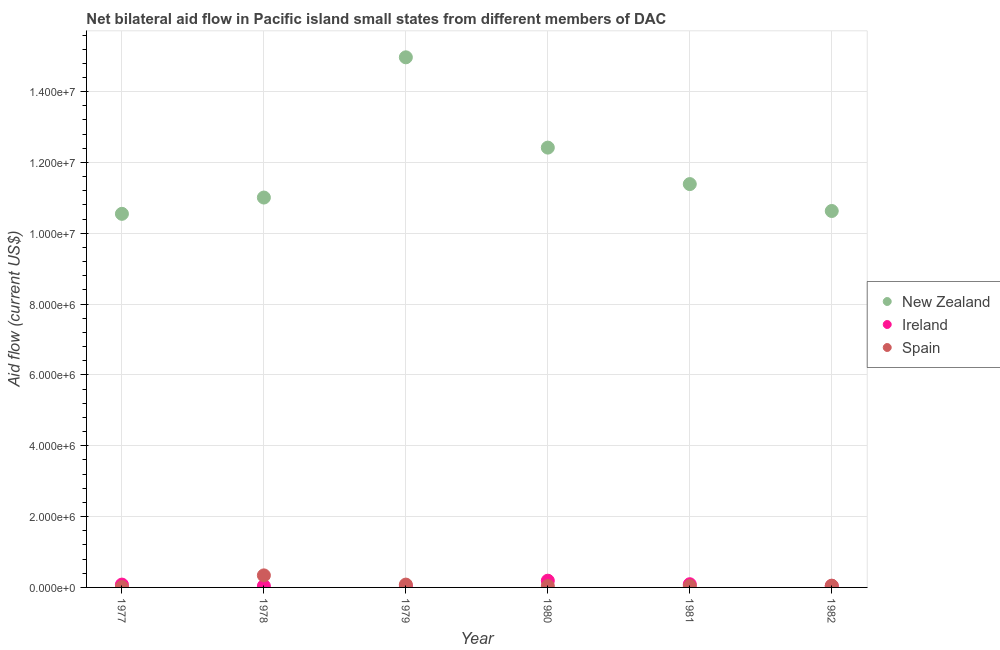How many different coloured dotlines are there?
Provide a succinct answer. 3. What is the amount of aid provided by new zealand in 1980?
Provide a succinct answer. 1.24e+07. Across all years, what is the maximum amount of aid provided by ireland?
Your answer should be very brief. 1.90e+05. Across all years, what is the minimum amount of aid provided by spain?
Your answer should be compact. 10000. In which year was the amount of aid provided by ireland minimum?
Your answer should be compact. 1978. What is the total amount of aid provided by spain in the graph?
Make the answer very short. 5.60e+05. What is the difference between the amount of aid provided by ireland in 1978 and that in 1981?
Your response must be concise. -5.00e+04. What is the difference between the amount of aid provided by ireland in 1982 and the amount of aid provided by new zealand in 1981?
Provide a succinct answer. -1.14e+07. What is the average amount of aid provided by spain per year?
Offer a terse response. 9.33e+04. In the year 1979, what is the difference between the amount of aid provided by spain and amount of aid provided by new zealand?
Make the answer very short. -1.49e+07. What is the ratio of the amount of aid provided by new zealand in 1979 to that in 1982?
Keep it short and to the point. 1.41. Is the difference between the amount of aid provided by spain in 1977 and 1978 greater than the difference between the amount of aid provided by ireland in 1977 and 1978?
Offer a very short reply. No. What is the difference between the highest and the lowest amount of aid provided by spain?
Provide a succinct answer. 3.30e+05. Is it the case that in every year, the sum of the amount of aid provided by new zealand and amount of aid provided by ireland is greater than the amount of aid provided by spain?
Give a very brief answer. Yes. How many dotlines are there?
Offer a very short reply. 3. How many years are there in the graph?
Make the answer very short. 6. Are the values on the major ticks of Y-axis written in scientific E-notation?
Offer a terse response. Yes. Does the graph contain any zero values?
Provide a succinct answer. No. Does the graph contain grids?
Give a very brief answer. Yes. How are the legend labels stacked?
Keep it short and to the point. Vertical. What is the title of the graph?
Offer a very short reply. Net bilateral aid flow in Pacific island small states from different members of DAC. Does "Tertiary" appear as one of the legend labels in the graph?
Your response must be concise. No. What is the label or title of the X-axis?
Ensure brevity in your answer.  Year. What is the label or title of the Y-axis?
Offer a terse response. Aid flow (current US$). What is the Aid flow (current US$) in New Zealand in 1977?
Make the answer very short. 1.06e+07. What is the Aid flow (current US$) in New Zealand in 1978?
Ensure brevity in your answer.  1.10e+07. What is the Aid flow (current US$) in Spain in 1978?
Your response must be concise. 3.40e+05. What is the Aid flow (current US$) in New Zealand in 1979?
Offer a very short reply. 1.50e+07. What is the Aid flow (current US$) in New Zealand in 1980?
Your answer should be compact. 1.24e+07. What is the Aid flow (current US$) of New Zealand in 1981?
Provide a short and direct response. 1.14e+07. What is the Aid flow (current US$) of Spain in 1981?
Keep it short and to the point. 4.00e+04. What is the Aid flow (current US$) of New Zealand in 1982?
Offer a terse response. 1.06e+07. Across all years, what is the maximum Aid flow (current US$) of New Zealand?
Keep it short and to the point. 1.50e+07. Across all years, what is the maximum Aid flow (current US$) of Ireland?
Your answer should be compact. 1.90e+05. Across all years, what is the maximum Aid flow (current US$) in Spain?
Give a very brief answer. 3.40e+05. Across all years, what is the minimum Aid flow (current US$) of New Zealand?
Provide a succinct answer. 1.06e+07. What is the total Aid flow (current US$) of New Zealand in the graph?
Offer a terse response. 7.10e+07. What is the total Aid flow (current US$) in Spain in the graph?
Ensure brevity in your answer.  5.60e+05. What is the difference between the Aid flow (current US$) of New Zealand in 1977 and that in 1978?
Your response must be concise. -4.60e+05. What is the difference between the Aid flow (current US$) in Ireland in 1977 and that in 1978?
Offer a very short reply. 4.00e+04. What is the difference between the Aid flow (current US$) in Spain in 1977 and that in 1978?
Your answer should be very brief. -3.30e+05. What is the difference between the Aid flow (current US$) of New Zealand in 1977 and that in 1979?
Keep it short and to the point. -4.42e+06. What is the difference between the Aid flow (current US$) of Ireland in 1977 and that in 1979?
Your answer should be compact. 4.00e+04. What is the difference between the Aid flow (current US$) in Spain in 1977 and that in 1979?
Keep it short and to the point. -7.00e+04. What is the difference between the Aid flow (current US$) of New Zealand in 1977 and that in 1980?
Provide a succinct answer. -1.87e+06. What is the difference between the Aid flow (current US$) in Ireland in 1977 and that in 1980?
Your response must be concise. -1.10e+05. What is the difference between the Aid flow (current US$) in New Zealand in 1977 and that in 1981?
Your answer should be compact. -8.40e+05. What is the difference between the Aid flow (current US$) in Spain in 1977 and that in 1981?
Your answer should be very brief. -3.00e+04. What is the difference between the Aid flow (current US$) in Ireland in 1977 and that in 1982?
Offer a terse response. 4.00e+04. What is the difference between the Aid flow (current US$) of Spain in 1977 and that in 1982?
Provide a short and direct response. -4.00e+04. What is the difference between the Aid flow (current US$) of New Zealand in 1978 and that in 1979?
Offer a terse response. -3.96e+06. What is the difference between the Aid flow (current US$) in Ireland in 1978 and that in 1979?
Ensure brevity in your answer.  0. What is the difference between the Aid flow (current US$) in New Zealand in 1978 and that in 1980?
Provide a short and direct response. -1.41e+06. What is the difference between the Aid flow (current US$) of Ireland in 1978 and that in 1980?
Keep it short and to the point. -1.50e+05. What is the difference between the Aid flow (current US$) in Spain in 1978 and that in 1980?
Your answer should be very brief. 3.00e+05. What is the difference between the Aid flow (current US$) of New Zealand in 1978 and that in 1981?
Ensure brevity in your answer.  -3.80e+05. What is the difference between the Aid flow (current US$) of New Zealand in 1978 and that in 1982?
Provide a succinct answer. 3.80e+05. What is the difference between the Aid flow (current US$) in Ireland in 1978 and that in 1982?
Keep it short and to the point. 0. What is the difference between the Aid flow (current US$) of New Zealand in 1979 and that in 1980?
Offer a very short reply. 2.55e+06. What is the difference between the Aid flow (current US$) in New Zealand in 1979 and that in 1981?
Provide a succinct answer. 3.58e+06. What is the difference between the Aid flow (current US$) of Ireland in 1979 and that in 1981?
Offer a very short reply. -5.00e+04. What is the difference between the Aid flow (current US$) of Spain in 1979 and that in 1981?
Your response must be concise. 4.00e+04. What is the difference between the Aid flow (current US$) in New Zealand in 1979 and that in 1982?
Make the answer very short. 4.34e+06. What is the difference between the Aid flow (current US$) in New Zealand in 1980 and that in 1981?
Provide a short and direct response. 1.03e+06. What is the difference between the Aid flow (current US$) in New Zealand in 1980 and that in 1982?
Provide a succinct answer. 1.79e+06. What is the difference between the Aid flow (current US$) in Ireland in 1980 and that in 1982?
Offer a very short reply. 1.50e+05. What is the difference between the Aid flow (current US$) in New Zealand in 1981 and that in 1982?
Your answer should be very brief. 7.60e+05. What is the difference between the Aid flow (current US$) in New Zealand in 1977 and the Aid flow (current US$) in Ireland in 1978?
Offer a terse response. 1.05e+07. What is the difference between the Aid flow (current US$) in New Zealand in 1977 and the Aid flow (current US$) in Spain in 1978?
Offer a terse response. 1.02e+07. What is the difference between the Aid flow (current US$) in Ireland in 1977 and the Aid flow (current US$) in Spain in 1978?
Give a very brief answer. -2.60e+05. What is the difference between the Aid flow (current US$) in New Zealand in 1977 and the Aid flow (current US$) in Ireland in 1979?
Your answer should be very brief. 1.05e+07. What is the difference between the Aid flow (current US$) in New Zealand in 1977 and the Aid flow (current US$) in Spain in 1979?
Ensure brevity in your answer.  1.05e+07. What is the difference between the Aid flow (current US$) of Ireland in 1977 and the Aid flow (current US$) of Spain in 1979?
Keep it short and to the point. 0. What is the difference between the Aid flow (current US$) in New Zealand in 1977 and the Aid flow (current US$) in Ireland in 1980?
Give a very brief answer. 1.04e+07. What is the difference between the Aid flow (current US$) of New Zealand in 1977 and the Aid flow (current US$) of Spain in 1980?
Your answer should be compact. 1.05e+07. What is the difference between the Aid flow (current US$) of New Zealand in 1977 and the Aid flow (current US$) of Ireland in 1981?
Your answer should be very brief. 1.05e+07. What is the difference between the Aid flow (current US$) in New Zealand in 1977 and the Aid flow (current US$) in Spain in 1981?
Your response must be concise. 1.05e+07. What is the difference between the Aid flow (current US$) of Ireland in 1977 and the Aid flow (current US$) of Spain in 1981?
Your answer should be compact. 4.00e+04. What is the difference between the Aid flow (current US$) in New Zealand in 1977 and the Aid flow (current US$) in Ireland in 1982?
Your answer should be compact. 1.05e+07. What is the difference between the Aid flow (current US$) in New Zealand in 1977 and the Aid flow (current US$) in Spain in 1982?
Provide a short and direct response. 1.05e+07. What is the difference between the Aid flow (current US$) of New Zealand in 1978 and the Aid flow (current US$) of Ireland in 1979?
Provide a short and direct response. 1.10e+07. What is the difference between the Aid flow (current US$) in New Zealand in 1978 and the Aid flow (current US$) in Spain in 1979?
Keep it short and to the point. 1.09e+07. What is the difference between the Aid flow (current US$) in New Zealand in 1978 and the Aid flow (current US$) in Ireland in 1980?
Your answer should be compact. 1.08e+07. What is the difference between the Aid flow (current US$) of New Zealand in 1978 and the Aid flow (current US$) of Spain in 1980?
Provide a short and direct response. 1.10e+07. What is the difference between the Aid flow (current US$) in New Zealand in 1978 and the Aid flow (current US$) in Ireland in 1981?
Keep it short and to the point. 1.09e+07. What is the difference between the Aid flow (current US$) in New Zealand in 1978 and the Aid flow (current US$) in Spain in 1981?
Your answer should be compact. 1.10e+07. What is the difference between the Aid flow (current US$) of New Zealand in 1978 and the Aid flow (current US$) of Ireland in 1982?
Give a very brief answer. 1.10e+07. What is the difference between the Aid flow (current US$) in New Zealand in 1978 and the Aid flow (current US$) in Spain in 1982?
Your response must be concise. 1.10e+07. What is the difference between the Aid flow (current US$) in Ireland in 1978 and the Aid flow (current US$) in Spain in 1982?
Provide a short and direct response. -10000. What is the difference between the Aid flow (current US$) of New Zealand in 1979 and the Aid flow (current US$) of Ireland in 1980?
Give a very brief answer. 1.48e+07. What is the difference between the Aid flow (current US$) of New Zealand in 1979 and the Aid flow (current US$) of Spain in 1980?
Provide a short and direct response. 1.49e+07. What is the difference between the Aid flow (current US$) of New Zealand in 1979 and the Aid flow (current US$) of Ireland in 1981?
Your answer should be compact. 1.49e+07. What is the difference between the Aid flow (current US$) of New Zealand in 1979 and the Aid flow (current US$) of Spain in 1981?
Your answer should be compact. 1.49e+07. What is the difference between the Aid flow (current US$) in Ireland in 1979 and the Aid flow (current US$) in Spain in 1981?
Your response must be concise. 0. What is the difference between the Aid flow (current US$) of New Zealand in 1979 and the Aid flow (current US$) of Ireland in 1982?
Your answer should be compact. 1.49e+07. What is the difference between the Aid flow (current US$) of New Zealand in 1979 and the Aid flow (current US$) of Spain in 1982?
Give a very brief answer. 1.49e+07. What is the difference between the Aid flow (current US$) of New Zealand in 1980 and the Aid flow (current US$) of Ireland in 1981?
Provide a short and direct response. 1.23e+07. What is the difference between the Aid flow (current US$) of New Zealand in 1980 and the Aid flow (current US$) of Spain in 1981?
Offer a very short reply. 1.24e+07. What is the difference between the Aid flow (current US$) in Ireland in 1980 and the Aid flow (current US$) in Spain in 1981?
Provide a short and direct response. 1.50e+05. What is the difference between the Aid flow (current US$) in New Zealand in 1980 and the Aid flow (current US$) in Ireland in 1982?
Provide a short and direct response. 1.24e+07. What is the difference between the Aid flow (current US$) in New Zealand in 1980 and the Aid flow (current US$) in Spain in 1982?
Make the answer very short. 1.24e+07. What is the difference between the Aid flow (current US$) in New Zealand in 1981 and the Aid flow (current US$) in Ireland in 1982?
Your response must be concise. 1.14e+07. What is the difference between the Aid flow (current US$) in New Zealand in 1981 and the Aid flow (current US$) in Spain in 1982?
Provide a short and direct response. 1.13e+07. What is the average Aid flow (current US$) in New Zealand per year?
Offer a very short reply. 1.18e+07. What is the average Aid flow (current US$) of Spain per year?
Your answer should be very brief. 9.33e+04. In the year 1977, what is the difference between the Aid flow (current US$) in New Zealand and Aid flow (current US$) in Ireland?
Give a very brief answer. 1.05e+07. In the year 1977, what is the difference between the Aid flow (current US$) of New Zealand and Aid flow (current US$) of Spain?
Offer a terse response. 1.05e+07. In the year 1977, what is the difference between the Aid flow (current US$) in Ireland and Aid flow (current US$) in Spain?
Make the answer very short. 7.00e+04. In the year 1978, what is the difference between the Aid flow (current US$) of New Zealand and Aid flow (current US$) of Ireland?
Your response must be concise. 1.10e+07. In the year 1978, what is the difference between the Aid flow (current US$) in New Zealand and Aid flow (current US$) in Spain?
Provide a succinct answer. 1.07e+07. In the year 1978, what is the difference between the Aid flow (current US$) in Ireland and Aid flow (current US$) in Spain?
Make the answer very short. -3.00e+05. In the year 1979, what is the difference between the Aid flow (current US$) in New Zealand and Aid flow (current US$) in Ireland?
Give a very brief answer. 1.49e+07. In the year 1979, what is the difference between the Aid flow (current US$) in New Zealand and Aid flow (current US$) in Spain?
Your response must be concise. 1.49e+07. In the year 1980, what is the difference between the Aid flow (current US$) in New Zealand and Aid flow (current US$) in Ireland?
Offer a terse response. 1.22e+07. In the year 1980, what is the difference between the Aid flow (current US$) of New Zealand and Aid flow (current US$) of Spain?
Offer a very short reply. 1.24e+07. In the year 1981, what is the difference between the Aid flow (current US$) in New Zealand and Aid flow (current US$) in Ireland?
Your answer should be very brief. 1.13e+07. In the year 1981, what is the difference between the Aid flow (current US$) of New Zealand and Aid flow (current US$) of Spain?
Your answer should be very brief. 1.14e+07. In the year 1981, what is the difference between the Aid flow (current US$) in Ireland and Aid flow (current US$) in Spain?
Provide a short and direct response. 5.00e+04. In the year 1982, what is the difference between the Aid flow (current US$) of New Zealand and Aid flow (current US$) of Ireland?
Provide a succinct answer. 1.06e+07. In the year 1982, what is the difference between the Aid flow (current US$) in New Zealand and Aid flow (current US$) in Spain?
Keep it short and to the point. 1.06e+07. In the year 1982, what is the difference between the Aid flow (current US$) of Ireland and Aid flow (current US$) of Spain?
Offer a terse response. -10000. What is the ratio of the Aid flow (current US$) in New Zealand in 1977 to that in 1978?
Make the answer very short. 0.96. What is the ratio of the Aid flow (current US$) of Spain in 1977 to that in 1978?
Provide a succinct answer. 0.03. What is the ratio of the Aid flow (current US$) in New Zealand in 1977 to that in 1979?
Make the answer very short. 0.7. What is the ratio of the Aid flow (current US$) in Spain in 1977 to that in 1979?
Offer a terse response. 0.12. What is the ratio of the Aid flow (current US$) in New Zealand in 1977 to that in 1980?
Provide a succinct answer. 0.85. What is the ratio of the Aid flow (current US$) of Ireland in 1977 to that in 1980?
Your response must be concise. 0.42. What is the ratio of the Aid flow (current US$) of Spain in 1977 to that in 1980?
Offer a very short reply. 0.25. What is the ratio of the Aid flow (current US$) of New Zealand in 1977 to that in 1981?
Give a very brief answer. 0.93. What is the ratio of the Aid flow (current US$) in Spain in 1977 to that in 1981?
Offer a very short reply. 0.25. What is the ratio of the Aid flow (current US$) of New Zealand in 1977 to that in 1982?
Your answer should be compact. 0.99. What is the ratio of the Aid flow (current US$) in Ireland in 1977 to that in 1982?
Provide a succinct answer. 2. What is the ratio of the Aid flow (current US$) in Spain in 1977 to that in 1982?
Keep it short and to the point. 0.2. What is the ratio of the Aid flow (current US$) in New Zealand in 1978 to that in 1979?
Offer a very short reply. 0.74. What is the ratio of the Aid flow (current US$) of Spain in 1978 to that in 1979?
Ensure brevity in your answer.  4.25. What is the ratio of the Aid flow (current US$) of New Zealand in 1978 to that in 1980?
Offer a very short reply. 0.89. What is the ratio of the Aid flow (current US$) of Ireland in 1978 to that in 1980?
Give a very brief answer. 0.21. What is the ratio of the Aid flow (current US$) of Spain in 1978 to that in 1980?
Offer a terse response. 8.5. What is the ratio of the Aid flow (current US$) in New Zealand in 1978 to that in 1981?
Your answer should be very brief. 0.97. What is the ratio of the Aid flow (current US$) in Ireland in 1978 to that in 1981?
Ensure brevity in your answer.  0.44. What is the ratio of the Aid flow (current US$) of Spain in 1978 to that in 1981?
Your answer should be compact. 8.5. What is the ratio of the Aid flow (current US$) of New Zealand in 1978 to that in 1982?
Your answer should be compact. 1.04. What is the ratio of the Aid flow (current US$) of Ireland in 1978 to that in 1982?
Provide a succinct answer. 1. What is the ratio of the Aid flow (current US$) in New Zealand in 1979 to that in 1980?
Your response must be concise. 1.21. What is the ratio of the Aid flow (current US$) of Ireland in 1979 to that in 1980?
Ensure brevity in your answer.  0.21. What is the ratio of the Aid flow (current US$) of New Zealand in 1979 to that in 1981?
Provide a succinct answer. 1.31. What is the ratio of the Aid flow (current US$) of Ireland in 1979 to that in 1981?
Your answer should be very brief. 0.44. What is the ratio of the Aid flow (current US$) of Spain in 1979 to that in 1981?
Give a very brief answer. 2. What is the ratio of the Aid flow (current US$) in New Zealand in 1979 to that in 1982?
Your answer should be compact. 1.41. What is the ratio of the Aid flow (current US$) of Spain in 1979 to that in 1982?
Provide a short and direct response. 1.6. What is the ratio of the Aid flow (current US$) of New Zealand in 1980 to that in 1981?
Your response must be concise. 1.09. What is the ratio of the Aid flow (current US$) in Ireland in 1980 to that in 1981?
Provide a succinct answer. 2.11. What is the ratio of the Aid flow (current US$) in Spain in 1980 to that in 1981?
Offer a terse response. 1. What is the ratio of the Aid flow (current US$) in New Zealand in 1980 to that in 1982?
Make the answer very short. 1.17. What is the ratio of the Aid flow (current US$) in Ireland in 1980 to that in 1982?
Give a very brief answer. 4.75. What is the ratio of the Aid flow (current US$) of Spain in 1980 to that in 1982?
Your response must be concise. 0.8. What is the ratio of the Aid flow (current US$) of New Zealand in 1981 to that in 1982?
Your answer should be very brief. 1.07. What is the ratio of the Aid flow (current US$) in Ireland in 1981 to that in 1982?
Keep it short and to the point. 2.25. What is the difference between the highest and the second highest Aid flow (current US$) of New Zealand?
Provide a succinct answer. 2.55e+06. What is the difference between the highest and the second highest Aid flow (current US$) of Ireland?
Offer a terse response. 1.00e+05. What is the difference between the highest and the second highest Aid flow (current US$) of Spain?
Provide a short and direct response. 2.60e+05. What is the difference between the highest and the lowest Aid flow (current US$) in New Zealand?
Offer a very short reply. 4.42e+06. What is the difference between the highest and the lowest Aid flow (current US$) of Ireland?
Give a very brief answer. 1.50e+05. 